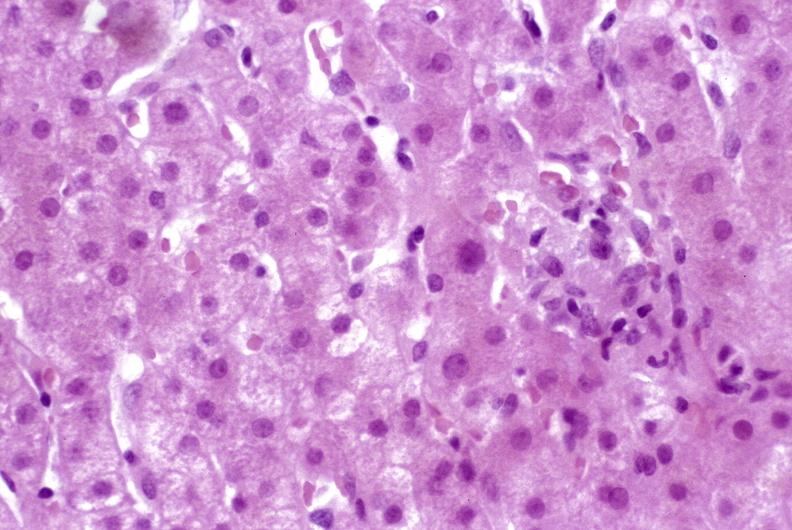what is present?
Answer the question using a single word or phrase. Hepatobiliary 